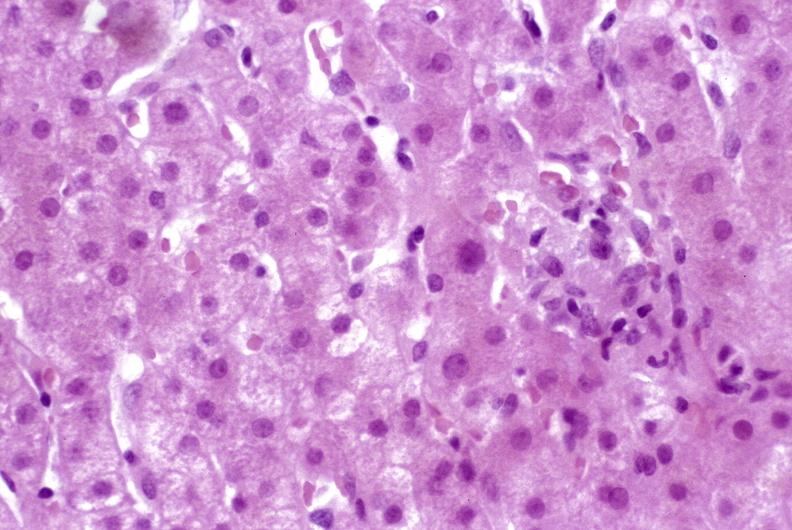what is present?
Answer the question using a single word or phrase. Hepatobiliary 